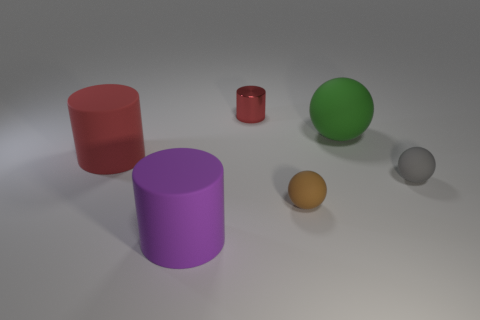Subtract all green spheres. How many spheres are left? 2 Add 2 small red objects. How many objects exist? 8 Subtract all gray spheres. How many spheres are left? 2 Subtract all brown cubes. How many red cylinders are left? 2 Add 1 cyan metal things. How many cyan metal things exist? 1 Subtract 0 green cylinders. How many objects are left? 6 Subtract all red cylinders. Subtract all gray blocks. How many cylinders are left? 1 Subtract all tiny balls. Subtract all red matte cylinders. How many objects are left? 3 Add 3 tiny red cylinders. How many tiny red cylinders are left? 4 